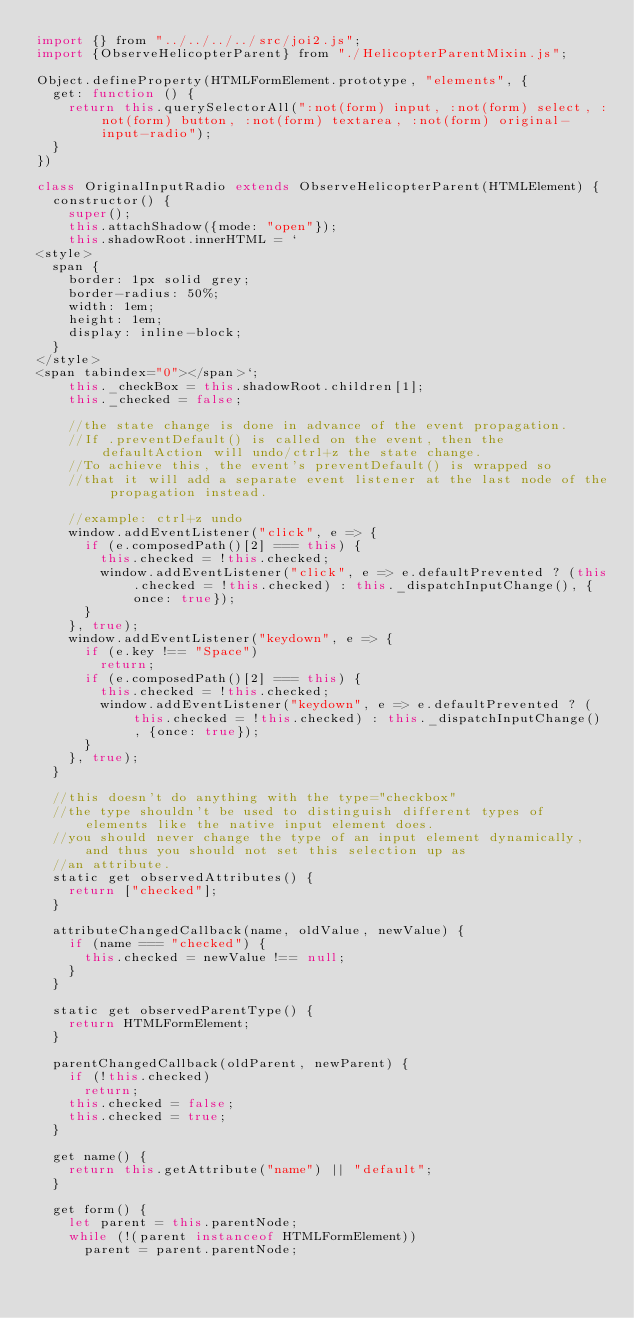<code> <loc_0><loc_0><loc_500><loc_500><_JavaScript_>import {} from "../../../../src/joi2.js";
import {ObserveHelicopterParent} from "./HelicopterParentMixin.js";

Object.defineProperty(HTMLFormElement.prototype, "elements", {
  get: function () {
    return this.querySelectorAll(":not(form) input, :not(form) select, :not(form) button, :not(form) textarea, :not(form) original-input-radio");
  }
})

class OriginalInputRadio extends ObserveHelicopterParent(HTMLElement) {
  constructor() {
    super();
    this.attachShadow({mode: "open"});
    this.shadowRoot.innerHTML = `
<style>
  span {
    border: 1px solid grey;
    border-radius: 50%;
    width: 1em;
    height: 1em;
    display: inline-block;
  }
</style>
<span tabindex="0"></span>`;
    this._checkBox = this.shadowRoot.children[1];
    this._checked = false;

    //the state change is done in advance of the event propagation.
    //If .preventDefault() is called on the event, then the defaultAction will undo/ctrl+z the state change.
    //To achieve this, the event's preventDefault() is wrapped so
    //that it will add a separate event listener at the last node of the propagation instead.

    //example: ctrl+z undo
    window.addEventListener("click", e => {
      if (e.composedPath()[2] === this) {
        this.checked = !this.checked;
        window.addEventListener("click", e => e.defaultPrevented ? (this.checked = !this.checked) : this._dispatchInputChange(), {once: true});
      }
    }, true);
    window.addEventListener("keydown", e => {
      if (e.key !== "Space")
        return;
      if (e.composedPath()[2] === this) {
        this.checked = !this.checked;
        window.addEventListener("keydown", e => e.defaultPrevented ? (this.checked = !this.checked) : this._dispatchInputChange(), {once: true});
      }
    }, true);
  }

  //this doesn't do anything with the type="checkbox"
  //the type shouldn't be used to distinguish different types of elements like the native input element does.
  //you should never change the type of an input element dynamically, and thus you should not set this selection up as
  //an attribute.
  static get observedAttributes() {
    return ["checked"];
  }

  attributeChangedCallback(name, oldValue, newValue) {
    if (name === "checked") {
      this.checked = newValue !== null;
    }
  }

  static get observedParentType() {
    return HTMLFormElement;
  }

  parentChangedCallback(oldParent, newParent) {
    if (!this.checked)
      return;
    this.checked = false;
    this.checked = true;
  }

  get name() {
    return this.getAttribute("name") || "default";
  }

  get form() {
    let parent = this.parentNode;
    while (!(parent instanceof HTMLFormElement))
      parent = parent.parentNode;</code> 